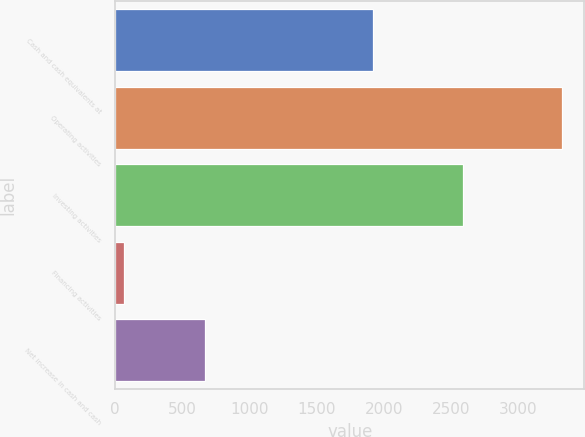<chart> <loc_0><loc_0><loc_500><loc_500><bar_chart><fcel>Cash and cash equivalents at<fcel>Operating activities<fcel>Investing activities<fcel>Financing activities<fcel>Net increase in cash and cash<nl><fcel>1920<fcel>3324<fcel>2590<fcel>70<fcel>667<nl></chart> 